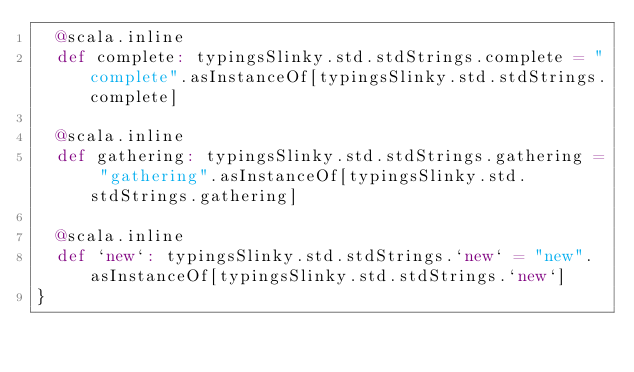Convert code to text. <code><loc_0><loc_0><loc_500><loc_500><_Scala_>  @scala.inline
  def complete: typingsSlinky.std.stdStrings.complete = "complete".asInstanceOf[typingsSlinky.std.stdStrings.complete]
  
  @scala.inline
  def gathering: typingsSlinky.std.stdStrings.gathering = "gathering".asInstanceOf[typingsSlinky.std.stdStrings.gathering]
  
  @scala.inline
  def `new`: typingsSlinky.std.stdStrings.`new` = "new".asInstanceOf[typingsSlinky.std.stdStrings.`new`]
}
</code> 